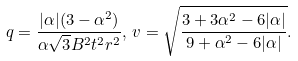Convert formula to latex. <formula><loc_0><loc_0><loc_500><loc_500>q = \frac { | \alpha | ( 3 - \alpha ^ { 2 } ) } { \alpha \sqrt { 3 } B ^ { 2 } t ^ { 2 } r ^ { 2 } } , \, v = \sqrt { \frac { 3 + 3 \alpha ^ { 2 } - 6 | \alpha | } { 9 + \alpha ^ { 2 } - 6 | \alpha | } } .</formula> 